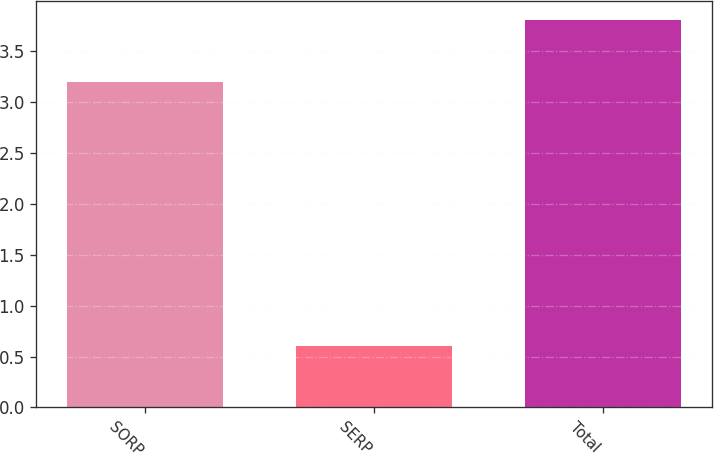<chart> <loc_0><loc_0><loc_500><loc_500><bar_chart><fcel>SORP<fcel>SERP<fcel>Total<nl><fcel>3.2<fcel>0.6<fcel>3.8<nl></chart> 